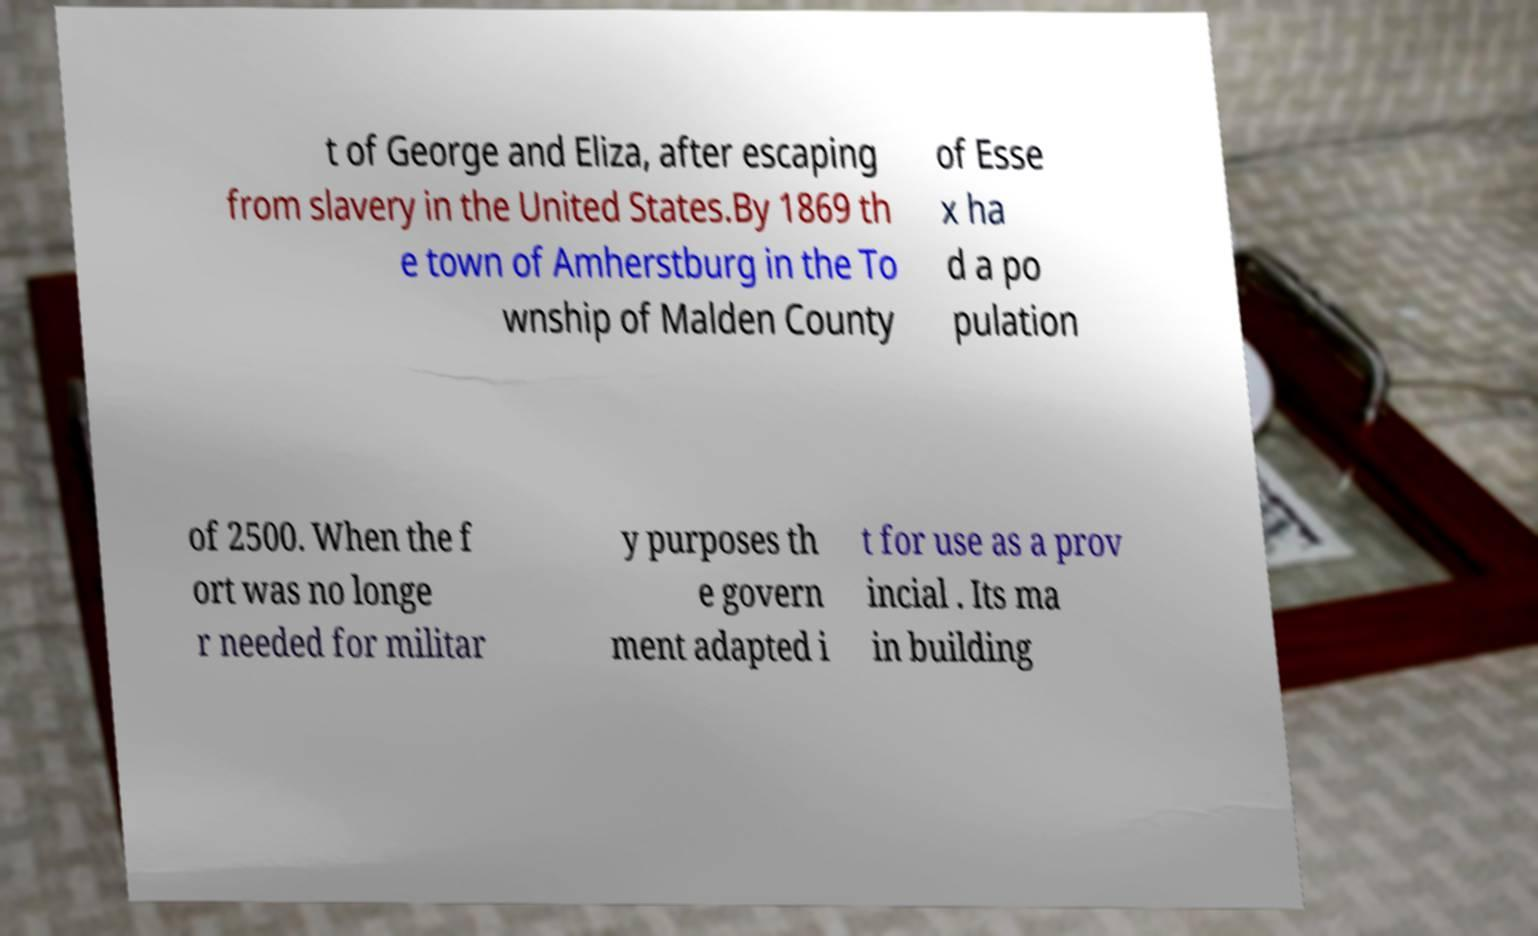Could you extract and type out the text from this image? t of George and Eliza, after escaping from slavery in the United States.By 1869 th e town of Amherstburg in the To wnship of Malden County of Esse x ha d a po pulation of 2500. When the f ort was no longe r needed for militar y purposes th e govern ment adapted i t for use as a prov incial . Its ma in building 